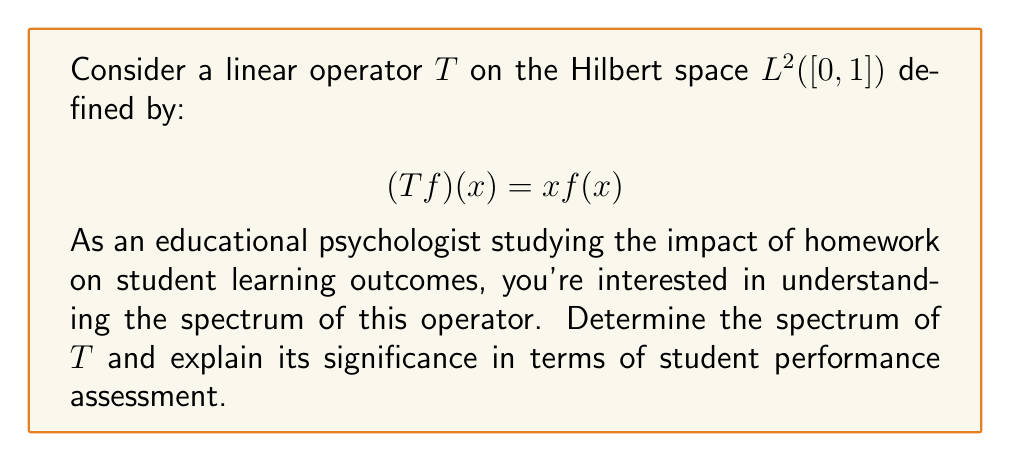Solve this math problem. To determine the spectrum of the linear operator $T$, we'll follow these steps:

1) First, recall that for a linear operator $T$ on a Hilbert space, the spectrum $\sigma(T)$ consists of all complex numbers $\lambda$ such that $(T - \lambda I)$ is not invertible.

2) In this case, for any $\lambda \in \mathbb{C}$, we have:

   $$(T - \lambda I)f(x) = xf(x) - \lambda f(x) = (x - \lambda)f(x)$$

3) For $(T - \lambda I)$ to be invertible, $(x - \lambda)$ must be non-zero for all $x \in [0,1]$.

4) This is only possible if $\lambda \notin [0,1]$. If $\lambda \in [0,1]$, there exists an $x \in [0,1]$ such that $x - \lambda = 0$, making $(T - \lambda I)$ not invertible.

5) Therefore, the spectrum of $T$ is $\sigma(T) = [0,1]$.

Significance in educational psychology:
The spectrum $[0,1]$ represents a continuous range of "eigenvalues" for this operator. In the context of student performance assessment:

- The lower end (near 0) might represent minimal impact of homework on learning outcomes.
- The upper end (near 1) could indicate maximum effectiveness of homework.
- The continuous nature suggests that the impact of homework on learning outcomes varies smoothly across different students or contexts.

This spectrum analysis could help in designing more effective homework strategies and understanding the variability in homework's impact on student learning.
Answer: $\sigma(T) = [0,1]$ 